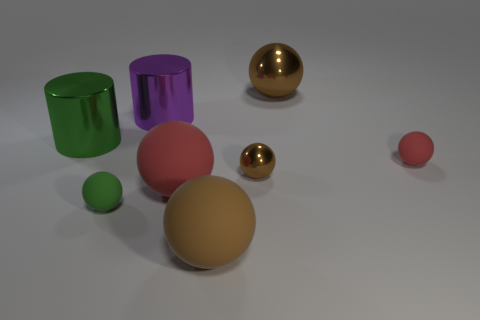How many brown spheres must be subtracted to get 1 brown spheres? 2 Subtract all green cubes. How many brown balls are left? 3 Subtract 3 spheres. How many spheres are left? 3 Subtract all green balls. How many balls are left? 5 Subtract all big red balls. How many balls are left? 5 Add 1 tiny brown balls. How many objects exist? 9 Subtract all yellow spheres. Subtract all blue blocks. How many spheres are left? 6 Subtract all cylinders. How many objects are left? 6 Add 2 large purple shiny cylinders. How many large purple shiny cylinders are left? 3 Add 5 tiny green spheres. How many tiny green spheres exist? 6 